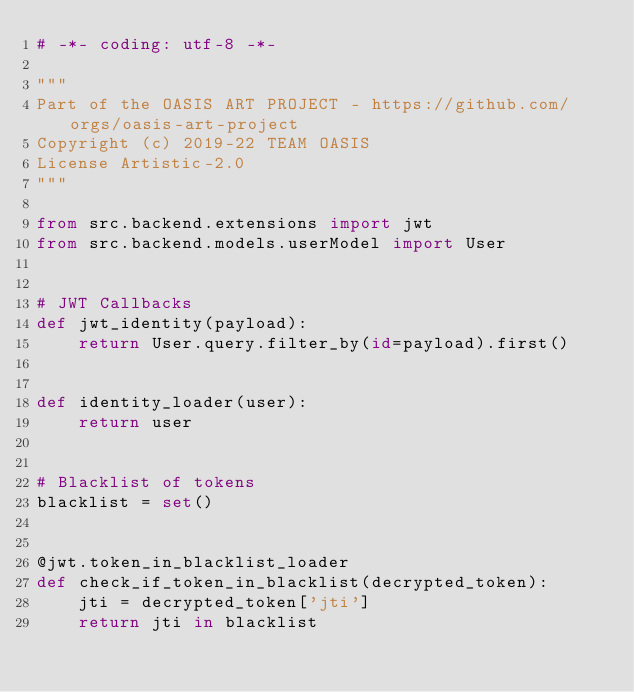Convert code to text. <code><loc_0><loc_0><loc_500><loc_500><_Python_># -*- coding: utf-8 -*-

"""
Part of the OASIS ART PROJECT - https://github.com/orgs/oasis-art-project
Copyright (c) 2019-22 TEAM OASIS
License Artistic-2.0
"""

from src.backend.extensions import jwt
from src.backend.models.userModel import User


# JWT Callbacks
def jwt_identity(payload):
    return User.query.filter_by(id=payload).first()


def identity_loader(user):
    return user


# Blacklist of tokens
blacklist = set()


@jwt.token_in_blacklist_loader
def check_if_token_in_blacklist(decrypted_token):
    jti = decrypted_token['jti']
    return jti in blacklist
</code> 